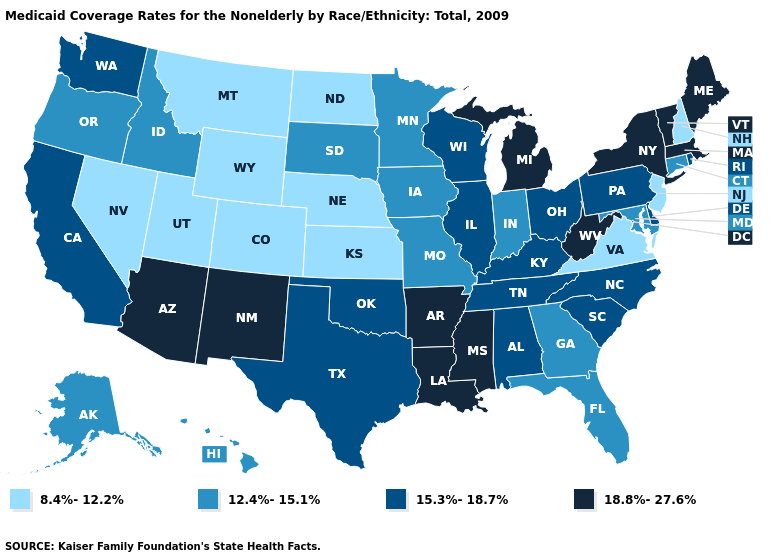What is the value of Nevada?
Write a very short answer. 8.4%-12.2%. Among the states that border Oregon , which have the lowest value?
Concise answer only. Nevada. Name the states that have a value in the range 12.4%-15.1%?
Short answer required. Alaska, Connecticut, Florida, Georgia, Hawaii, Idaho, Indiana, Iowa, Maryland, Minnesota, Missouri, Oregon, South Dakota. Name the states that have a value in the range 18.8%-27.6%?
Keep it brief. Arizona, Arkansas, Louisiana, Maine, Massachusetts, Michigan, Mississippi, New Mexico, New York, Vermont, West Virginia. Among the states that border California , which have the highest value?
Answer briefly. Arizona. What is the lowest value in states that border Tennessee?
Be succinct. 8.4%-12.2%. What is the highest value in the USA?
Concise answer only. 18.8%-27.6%. What is the highest value in the South ?
Concise answer only. 18.8%-27.6%. What is the value of New Mexico?
Quick response, please. 18.8%-27.6%. Which states have the lowest value in the USA?
Short answer required. Colorado, Kansas, Montana, Nebraska, Nevada, New Hampshire, New Jersey, North Dakota, Utah, Virginia, Wyoming. Among the states that border Ohio , does Indiana have the highest value?
Concise answer only. No. What is the lowest value in the MidWest?
Give a very brief answer. 8.4%-12.2%. Name the states that have a value in the range 8.4%-12.2%?
Short answer required. Colorado, Kansas, Montana, Nebraska, Nevada, New Hampshire, New Jersey, North Dakota, Utah, Virginia, Wyoming. Name the states that have a value in the range 8.4%-12.2%?
Short answer required. Colorado, Kansas, Montana, Nebraska, Nevada, New Hampshire, New Jersey, North Dakota, Utah, Virginia, Wyoming. 